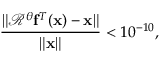<formula> <loc_0><loc_0><loc_500><loc_500>\frac { \| \ m a t h s c r R ^ { \theta } \mathbf f ^ { T } ( \mathbf x ) - \mathbf x \| } { \| \mathbf x \| } < 1 0 ^ { - 1 0 } ,</formula> 